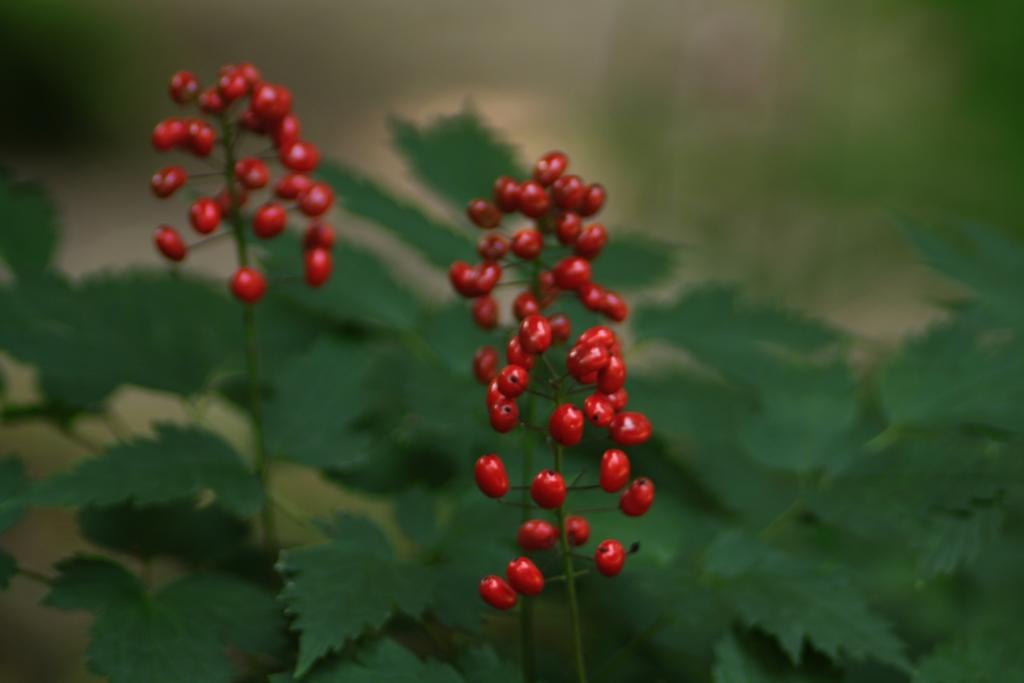In one or two sentences, can you explain what this image depicts? In this image I can see number of red colour berries and green colour leaves. I can also see this image is little bit blurry from background. 